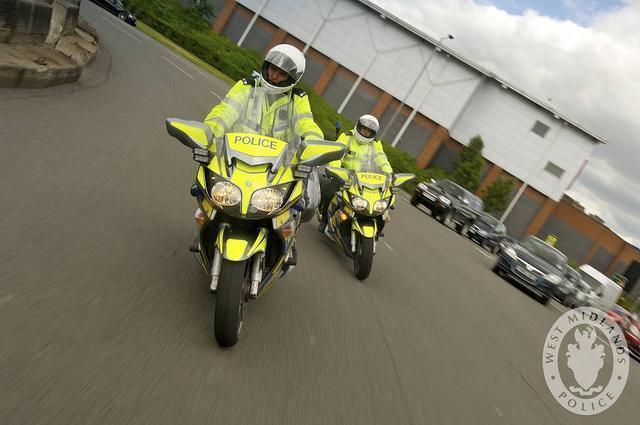How many wheels does the yellow bike have?
Give a very brief answer. 2. How many cars are visible?
Give a very brief answer. 1. How many motorcycles can you see?
Give a very brief answer. 2. How many people can be seen?
Give a very brief answer. 2. 